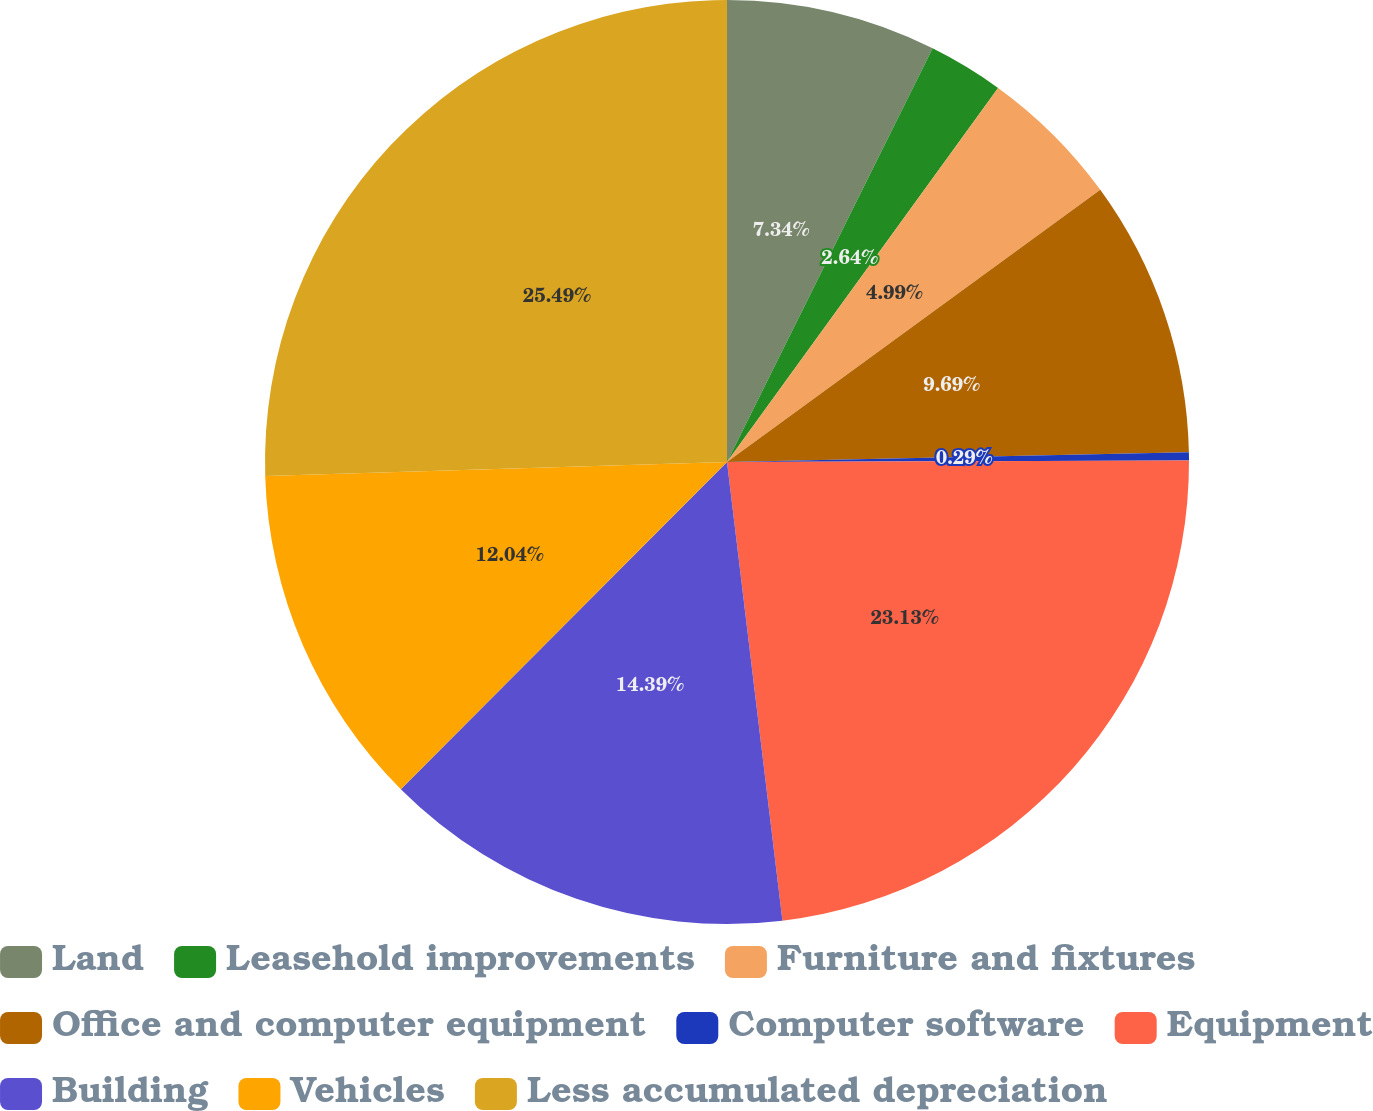Convert chart. <chart><loc_0><loc_0><loc_500><loc_500><pie_chart><fcel>Land<fcel>Leasehold improvements<fcel>Furniture and fixtures<fcel>Office and computer equipment<fcel>Computer software<fcel>Equipment<fcel>Building<fcel>Vehicles<fcel>Less accumulated depreciation<nl><fcel>7.34%<fcel>2.64%<fcel>4.99%<fcel>9.69%<fcel>0.29%<fcel>23.13%<fcel>14.39%<fcel>12.04%<fcel>25.48%<nl></chart> 